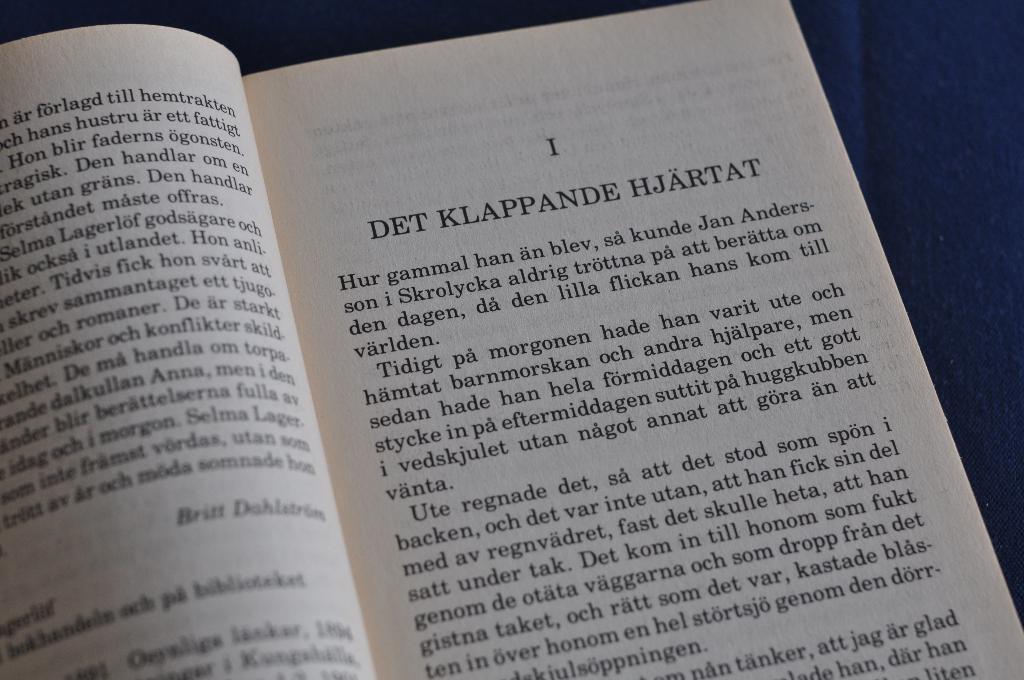That is the title of chapter i?
Make the answer very short. Det klappande hjartat. What is the chapter number?
Offer a very short reply. 1. 